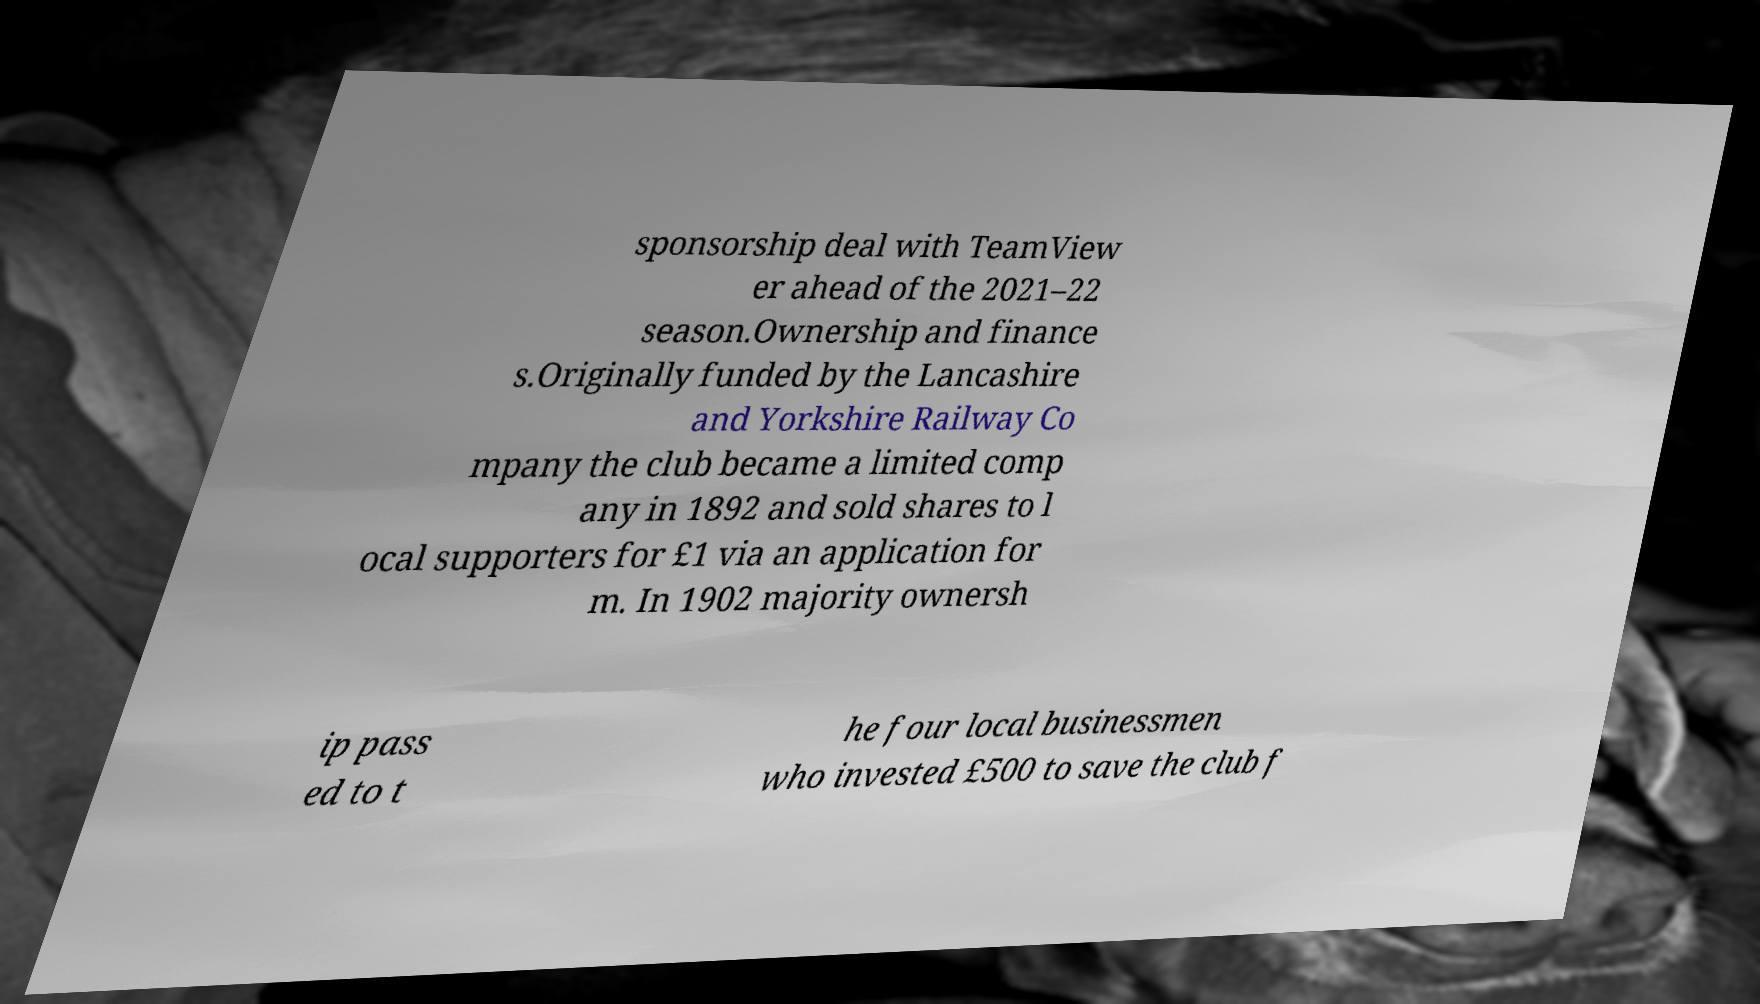Can you read and provide the text displayed in the image?This photo seems to have some interesting text. Can you extract and type it out for me? sponsorship deal with TeamView er ahead of the 2021–22 season.Ownership and finance s.Originally funded by the Lancashire and Yorkshire Railway Co mpany the club became a limited comp any in 1892 and sold shares to l ocal supporters for £1 via an application for m. In 1902 majority ownersh ip pass ed to t he four local businessmen who invested £500 to save the club f 